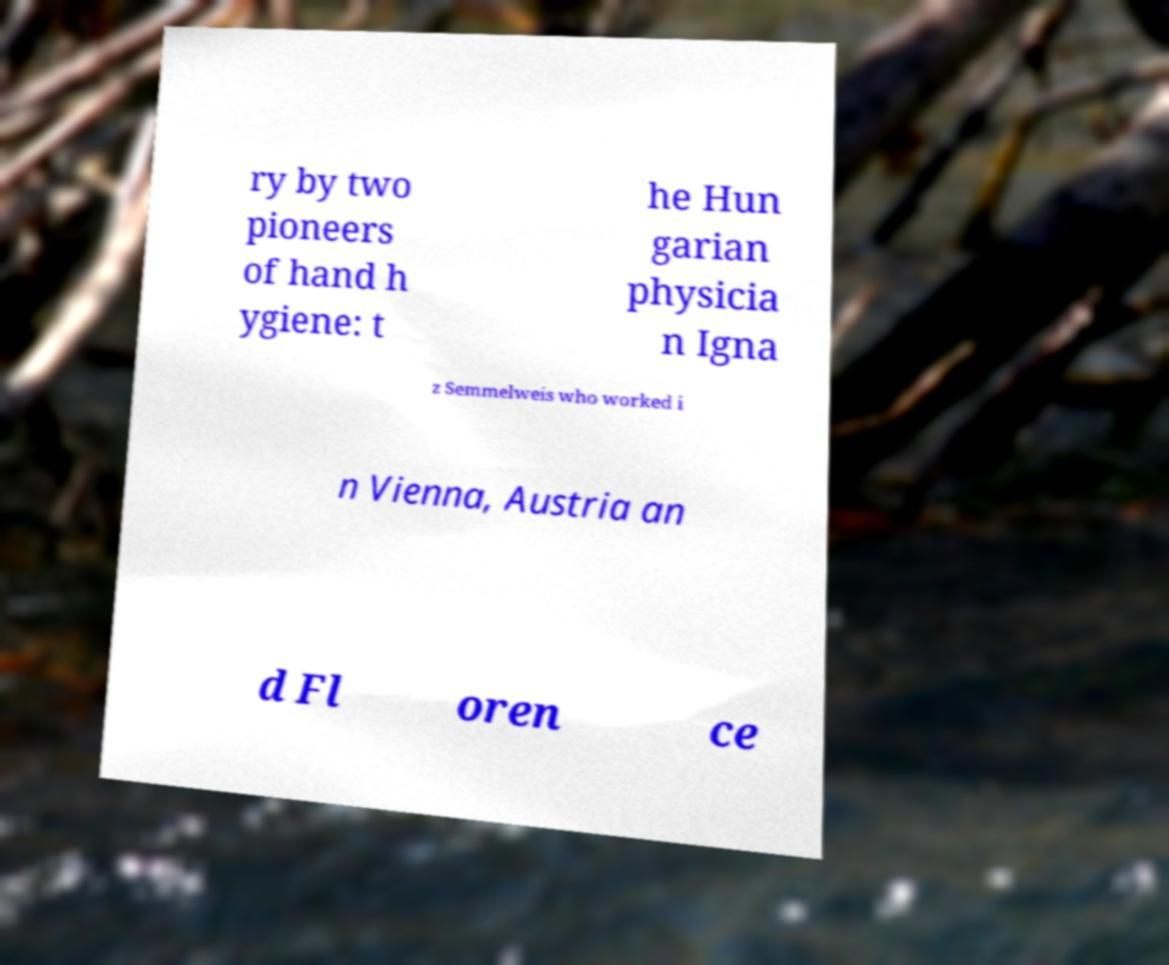Could you assist in decoding the text presented in this image and type it out clearly? ry by two pioneers of hand h ygiene: t he Hun garian physicia n Igna z Semmelweis who worked i n Vienna, Austria an d Fl oren ce 